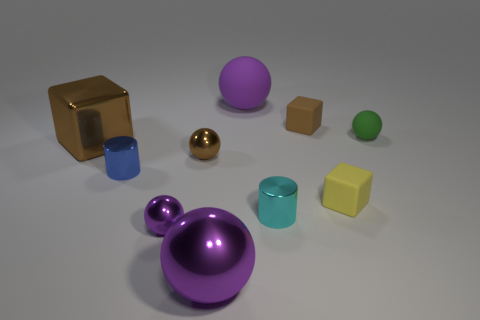Is there anything else that has the same color as the tiny matte sphere?
Offer a terse response. No. Do the large metallic ball and the big matte ball have the same color?
Offer a very short reply. Yes. Is the number of tiny shiny objects that are on the right side of the big brown cube greater than the number of big purple metallic spheres?
Provide a short and direct response. Yes. What number of other things are the same material as the tiny cyan thing?
Offer a terse response. 5. What number of large objects are either green matte blocks or green balls?
Your answer should be very brief. 0. Does the tiny green sphere have the same material as the small blue cylinder?
Offer a terse response. No. There is a purple object behind the cyan shiny object; how many small metal objects are on the right side of it?
Offer a very short reply. 1. Is there another metallic object that has the same shape as the large purple metal thing?
Offer a terse response. Yes. There is a large shiny thing that is behind the brown metal sphere; does it have the same shape as the tiny matte object in front of the small green ball?
Offer a terse response. Yes. What shape is the small metal object that is right of the tiny purple object and behind the yellow matte object?
Your response must be concise. Sphere. 